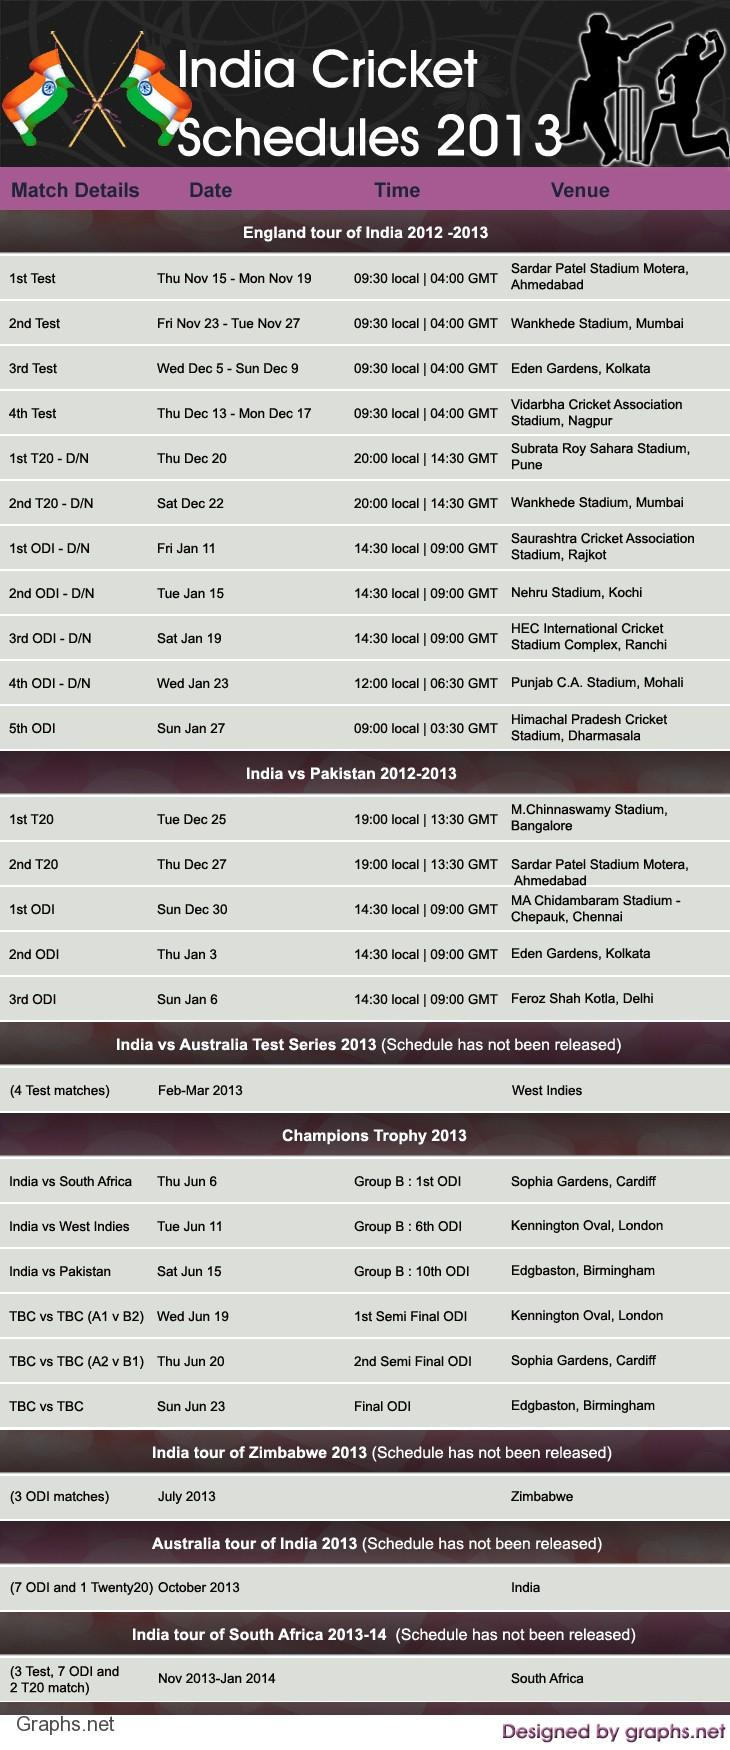Identify some key points in this picture. During the England tour of India in 2012-2013, a total of 20 Twenty 20 International matches were scheduled. Fifteen ODIs were scheduled during the England tour of India in 2012-2013. During the England tour of India in 2012-2013, a total of 4 test matches were scheduled. The first T20 match between India and Pakistan in the 2012-2013 season was scheduled to take place at the M.Chinnaswamy Stadium in Bangalore. In 2012-2013, a total of 3 ODIs were scheduled between India and Pakistan. 